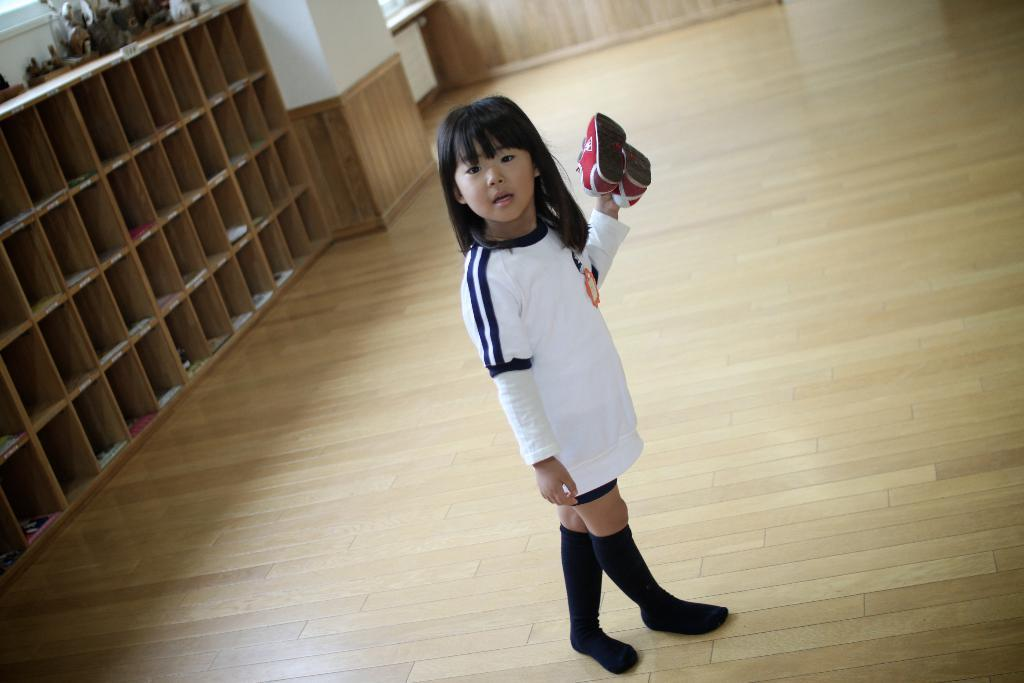Who is the main subject in the image? There is a girl in the image. What is the girl holding in her hand? The girl is holding shoes in her hand. Where is the girl standing in the image? The girl is standing on a path in the image. What other objects can be seen in the image? There is a wooden rack and a pillar on the left side of the image. What type of slope can be seen in the image? There is no slope present in the image. Is there a truck visible in the image? No, there is no truck present in the image. 